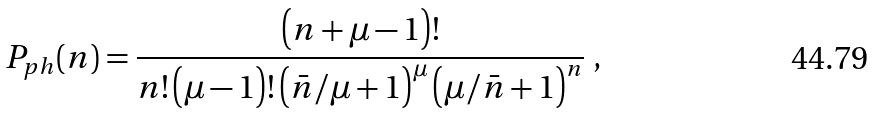Convert formula to latex. <formula><loc_0><loc_0><loc_500><loc_500>P _ { p h } ( n ) = \frac { \left ( n + \mu - 1 \right ) ! } { n ! \left ( \mu - 1 \right ) ! \left ( \bar { n } / \mu + 1 \right ) ^ { \mu } \left ( \mu / \bar { n } + 1 \right ) ^ { n } } \ ,</formula> 